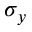<formula> <loc_0><loc_0><loc_500><loc_500>\sigma _ { y }</formula> 